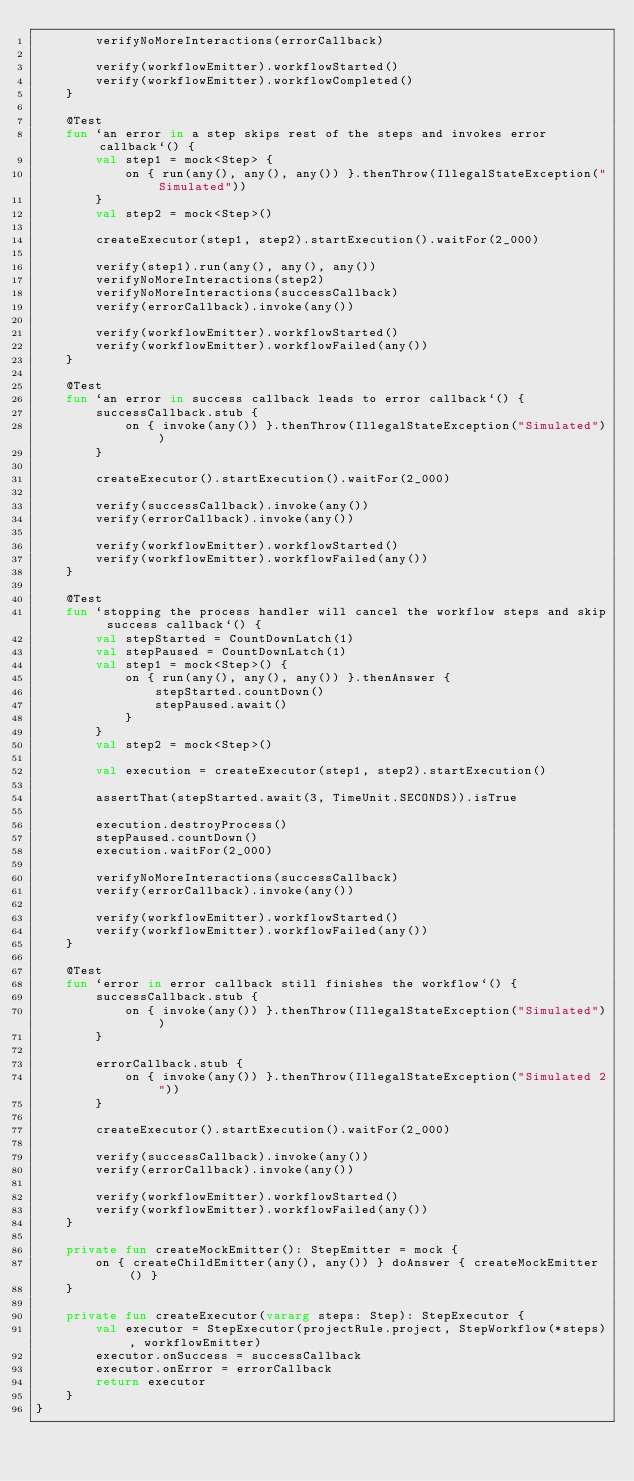Convert code to text. <code><loc_0><loc_0><loc_500><loc_500><_Kotlin_>        verifyNoMoreInteractions(errorCallback)

        verify(workflowEmitter).workflowStarted()
        verify(workflowEmitter).workflowCompleted()
    }

    @Test
    fun `an error in a step skips rest of the steps and invokes error callback`() {
        val step1 = mock<Step> {
            on { run(any(), any(), any()) }.thenThrow(IllegalStateException("Simulated"))
        }
        val step2 = mock<Step>()

        createExecutor(step1, step2).startExecution().waitFor(2_000)

        verify(step1).run(any(), any(), any())
        verifyNoMoreInteractions(step2)
        verifyNoMoreInteractions(successCallback)
        verify(errorCallback).invoke(any())

        verify(workflowEmitter).workflowStarted()
        verify(workflowEmitter).workflowFailed(any())
    }

    @Test
    fun `an error in success callback leads to error callback`() {
        successCallback.stub {
            on { invoke(any()) }.thenThrow(IllegalStateException("Simulated"))
        }

        createExecutor().startExecution().waitFor(2_000)

        verify(successCallback).invoke(any())
        verify(errorCallback).invoke(any())

        verify(workflowEmitter).workflowStarted()
        verify(workflowEmitter).workflowFailed(any())
    }

    @Test
    fun `stopping the process handler will cancel the workflow steps and skip success callback`() {
        val stepStarted = CountDownLatch(1)
        val stepPaused = CountDownLatch(1)
        val step1 = mock<Step>() {
            on { run(any(), any(), any()) }.thenAnswer {
                stepStarted.countDown()
                stepPaused.await()
            }
        }
        val step2 = mock<Step>()

        val execution = createExecutor(step1, step2).startExecution()

        assertThat(stepStarted.await(3, TimeUnit.SECONDS)).isTrue

        execution.destroyProcess()
        stepPaused.countDown()
        execution.waitFor(2_000)

        verifyNoMoreInteractions(successCallback)
        verify(errorCallback).invoke(any())

        verify(workflowEmitter).workflowStarted()
        verify(workflowEmitter).workflowFailed(any())
    }

    @Test
    fun `error in error callback still finishes the workflow`() {
        successCallback.stub {
            on { invoke(any()) }.thenThrow(IllegalStateException("Simulated"))
        }

        errorCallback.stub {
            on { invoke(any()) }.thenThrow(IllegalStateException("Simulated 2"))
        }

        createExecutor().startExecution().waitFor(2_000)

        verify(successCallback).invoke(any())
        verify(errorCallback).invoke(any())

        verify(workflowEmitter).workflowStarted()
        verify(workflowEmitter).workflowFailed(any())
    }

    private fun createMockEmitter(): StepEmitter = mock {
        on { createChildEmitter(any(), any()) } doAnswer { createMockEmitter() }
    }

    private fun createExecutor(vararg steps: Step): StepExecutor {
        val executor = StepExecutor(projectRule.project, StepWorkflow(*steps), workflowEmitter)
        executor.onSuccess = successCallback
        executor.onError = errorCallback
        return executor
    }
}
</code> 